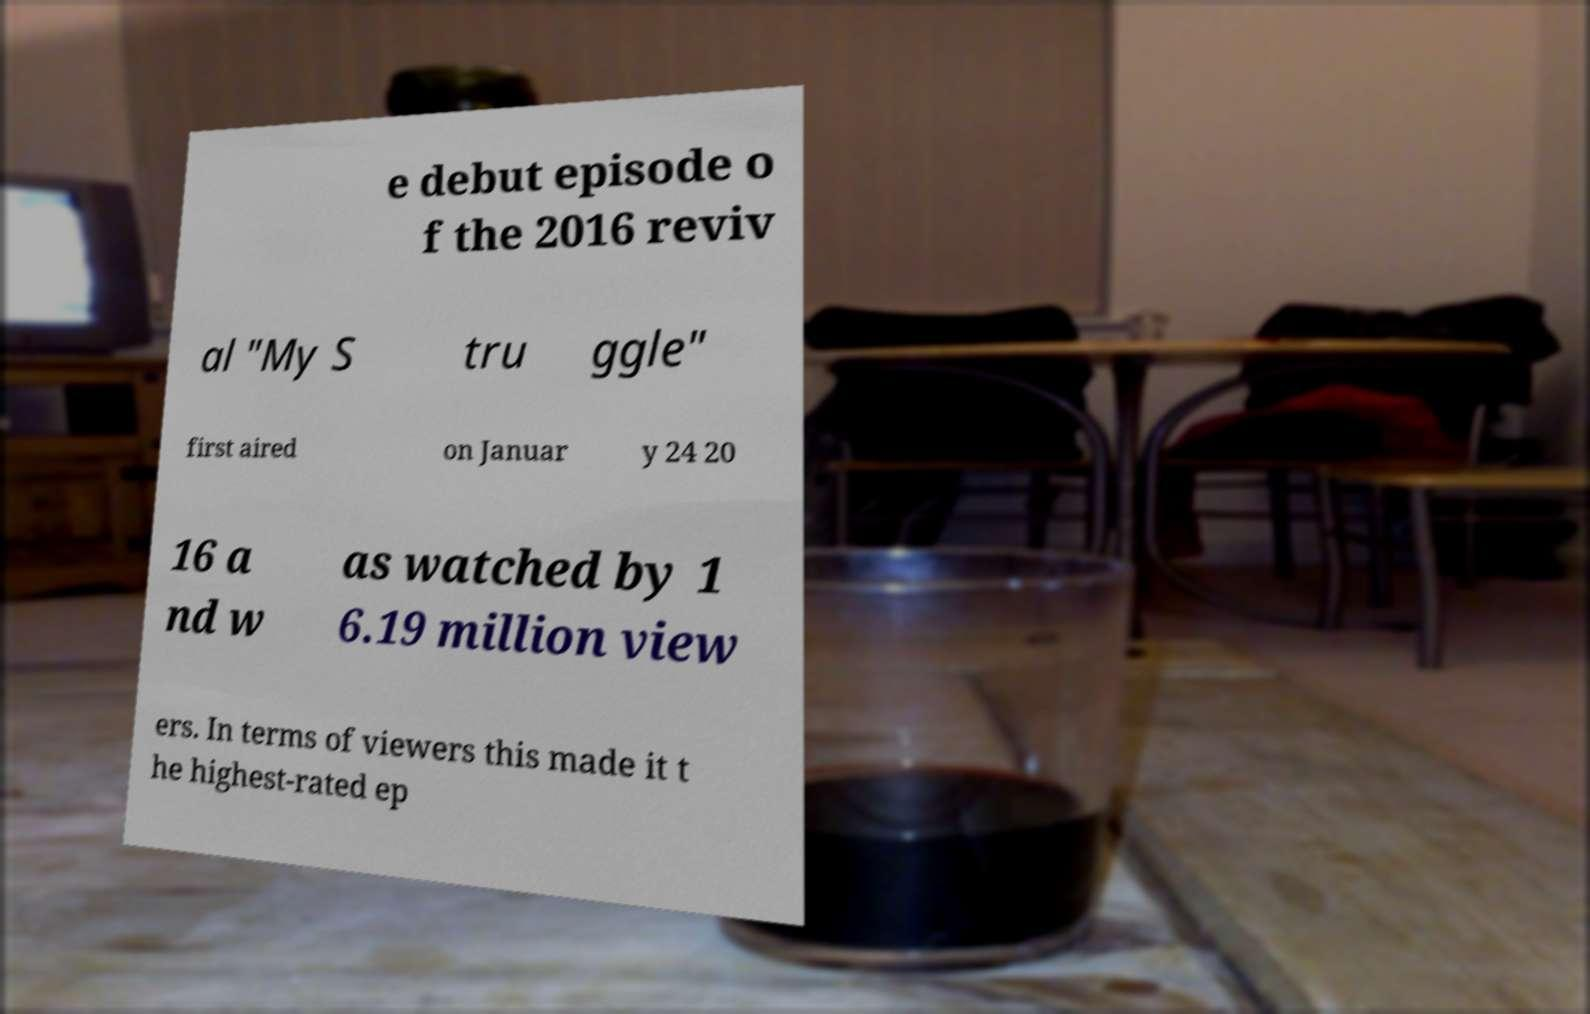What messages or text are displayed in this image? I need them in a readable, typed format. e debut episode o f the 2016 reviv al "My S tru ggle" first aired on Januar y 24 20 16 a nd w as watched by 1 6.19 million view ers. In terms of viewers this made it t he highest-rated ep 